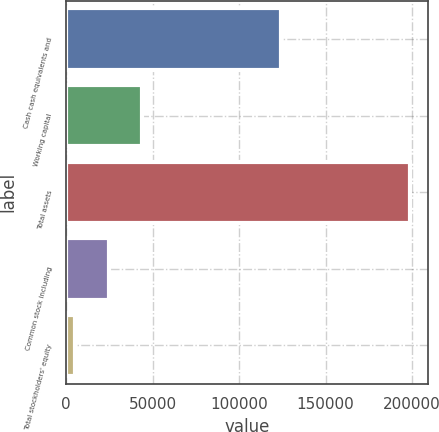Convert chart to OTSL. <chart><loc_0><loc_0><loc_500><loc_500><bar_chart><fcel>Cash cash equivalents and<fcel>Working capital<fcel>Total assets<fcel>Common stock including<fcel>Total stockholders' equity<nl><fcel>124190<fcel>44004.2<fcel>199105<fcel>24616.6<fcel>5229<nl></chart> 